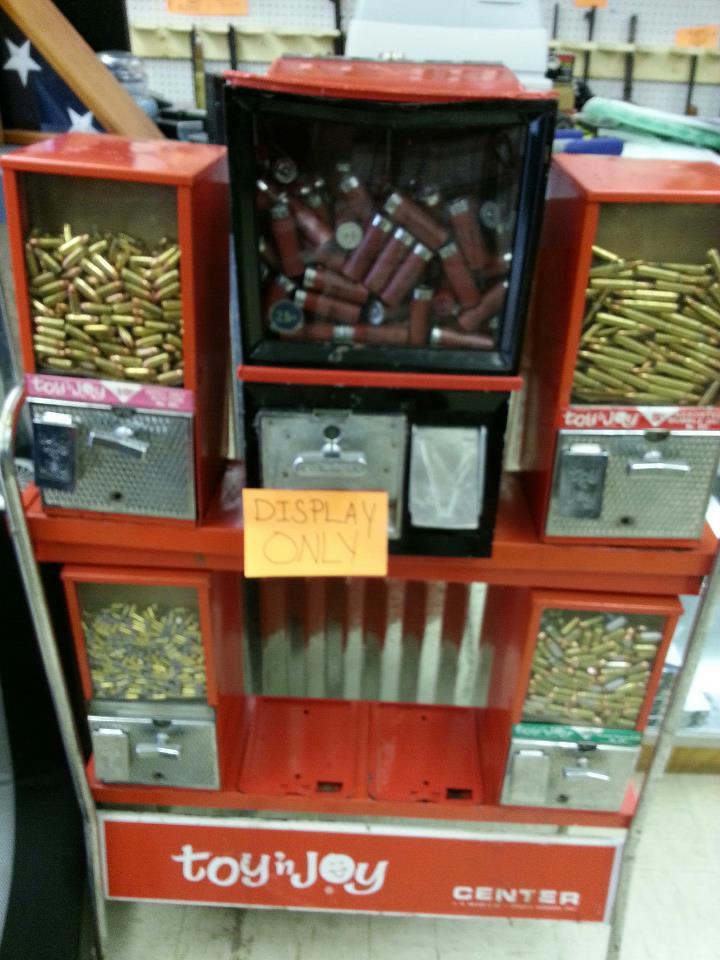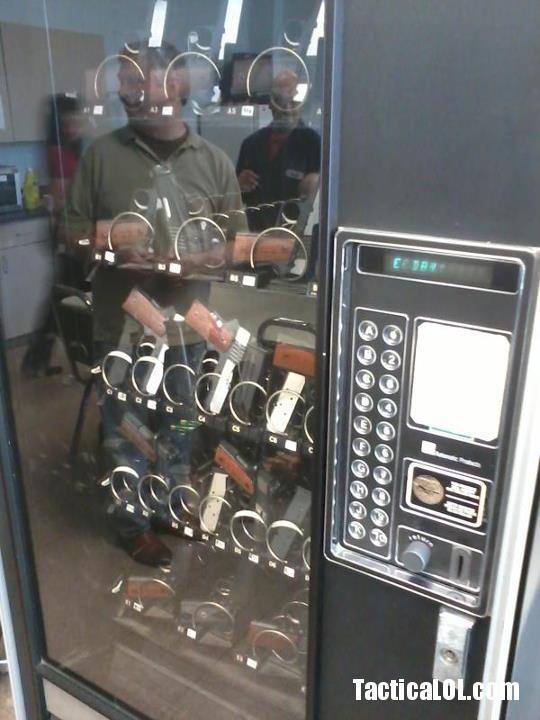The first image is the image on the left, the second image is the image on the right. For the images shown, is this caption "One of these machines is red." true? Answer yes or no. Yes. 